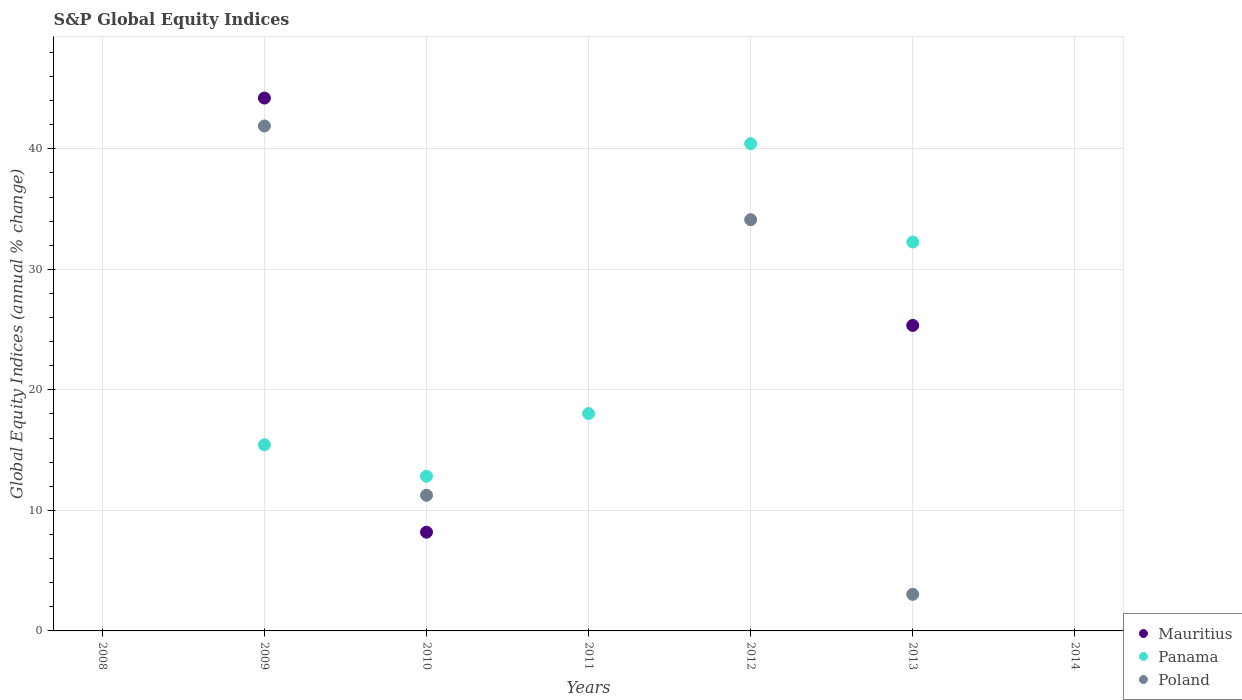What is the global equity indices in Panama in 2011?
Offer a very short reply. 18.04. Across all years, what is the maximum global equity indices in Mauritius?
Your answer should be very brief. 44.22. Across all years, what is the minimum global equity indices in Poland?
Offer a terse response. 0. In which year was the global equity indices in Panama maximum?
Your answer should be very brief. 2012. What is the total global equity indices in Panama in the graph?
Offer a terse response. 119.02. What is the difference between the global equity indices in Poland in 2009 and that in 2010?
Keep it short and to the point. 30.64. What is the difference between the global equity indices in Mauritius in 2011 and the global equity indices in Poland in 2012?
Make the answer very short. -34.12. What is the average global equity indices in Mauritius per year?
Offer a terse response. 11.11. In the year 2010, what is the difference between the global equity indices in Poland and global equity indices in Panama?
Your answer should be very brief. -1.58. Is the global equity indices in Poland in 2012 less than that in 2013?
Keep it short and to the point. No. What is the difference between the highest and the second highest global equity indices in Poland?
Your response must be concise. 7.78. What is the difference between the highest and the lowest global equity indices in Panama?
Keep it short and to the point. 40.43. In how many years, is the global equity indices in Mauritius greater than the average global equity indices in Mauritius taken over all years?
Give a very brief answer. 2. Does the global equity indices in Poland monotonically increase over the years?
Keep it short and to the point. No. Is the global equity indices in Panama strictly less than the global equity indices in Mauritius over the years?
Provide a short and direct response. No. How many dotlines are there?
Give a very brief answer. 3. What is the difference between two consecutive major ticks on the Y-axis?
Offer a very short reply. 10. Are the values on the major ticks of Y-axis written in scientific E-notation?
Make the answer very short. No. Does the graph contain any zero values?
Your answer should be compact. Yes. Where does the legend appear in the graph?
Your response must be concise. Bottom right. How are the legend labels stacked?
Your response must be concise. Vertical. What is the title of the graph?
Offer a terse response. S&P Global Equity Indices. What is the label or title of the X-axis?
Your answer should be compact. Years. What is the label or title of the Y-axis?
Offer a terse response. Global Equity Indices (annual % change). What is the Global Equity Indices (annual % change) of Panama in 2008?
Offer a very short reply. 0. What is the Global Equity Indices (annual % change) in Poland in 2008?
Your answer should be compact. 0. What is the Global Equity Indices (annual % change) in Mauritius in 2009?
Provide a succinct answer. 44.22. What is the Global Equity Indices (annual % change) in Panama in 2009?
Your answer should be very brief. 15.45. What is the Global Equity Indices (annual % change) of Poland in 2009?
Provide a succinct answer. 41.9. What is the Global Equity Indices (annual % change) in Mauritius in 2010?
Offer a very short reply. 8.19. What is the Global Equity Indices (annual % change) in Panama in 2010?
Keep it short and to the point. 12.83. What is the Global Equity Indices (annual % change) of Poland in 2010?
Make the answer very short. 11.26. What is the Global Equity Indices (annual % change) in Mauritius in 2011?
Offer a terse response. 0. What is the Global Equity Indices (annual % change) of Panama in 2011?
Your answer should be compact. 18.04. What is the Global Equity Indices (annual % change) of Poland in 2011?
Offer a very short reply. 0. What is the Global Equity Indices (annual % change) of Mauritius in 2012?
Your answer should be compact. 0. What is the Global Equity Indices (annual % change) of Panama in 2012?
Provide a short and direct response. 40.43. What is the Global Equity Indices (annual % change) in Poland in 2012?
Your answer should be compact. 34.12. What is the Global Equity Indices (annual % change) in Mauritius in 2013?
Give a very brief answer. 25.35. What is the Global Equity Indices (annual % change) of Panama in 2013?
Your response must be concise. 32.27. What is the Global Equity Indices (annual % change) in Poland in 2013?
Your answer should be very brief. 3.04. What is the Global Equity Indices (annual % change) of Mauritius in 2014?
Keep it short and to the point. 0. What is the Global Equity Indices (annual % change) of Panama in 2014?
Provide a short and direct response. 0. What is the Global Equity Indices (annual % change) in Poland in 2014?
Keep it short and to the point. 0. Across all years, what is the maximum Global Equity Indices (annual % change) in Mauritius?
Keep it short and to the point. 44.22. Across all years, what is the maximum Global Equity Indices (annual % change) in Panama?
Keep it short and to the point. 40.43. Across all years, what is the maximum Global Equity Indices (annual % change) in Poland?
Make the answer very short. 41.9. Across all years, what is the minimum Global Equity Indices (annual % change) of Poland?
Your answer should be very brief. 0. What is the total Global Equity Indices (annual % change) of Mauritius in the graph?
Your answer should be very brief. 77.76. What is the total Global Equity Indices (annual % change) of Panama in the graph?
Give a very brief answer. 119.02. What is the total Global Equity Indices (annual % change) in Poland in the graph?
Offer a terse response. 90.32. What is the difference between the Global Equity Indices (annual % change) of Mauritius in 2009 and that in 2010?
Provide a short and direct response. 36.02. What is the difference between the Global Equity Indices (annual % change) of Panama in 2009 and that in 2010?
Make the answer very short. 2.61. What is the difference between the Global Equity Indices (annual % change) in Poland in 2009 and that in 2010?
Provide a succinct answer. 30.64. What is the difference between the Global Equity Indices (annual % change) in Panama in 2009 and that in 2011?
Keep it short and to the point. -2.59. What is the difference between the Global Equity Indices (annual % change) in Panama in 2009 and that in 2012?
Provide a succinct answer. -24.98. What is the difference between the Global Equity Indices (annual % change) in Poland in 2009 and that in 2012?
Ensure brevity in your answer.  7.78. What is the difference between the Global Equity Indices (annual % change) in Mauritius in 2009 and that in 2013?
Provide a short and direct response. 18.87. What is the difference between the Global Equity Indices (annual % change) of Panama in 2009 and that in 2013?
Your response must be concise. -16.82. What is the difference between the Global Equity Indices (annual % change) in Poland in 2009 and that in 2013?
Ensure brevity in your answer.  38.86. What is the difference between the Global Equity Indices (annual % change) in Panama in 2010 and that in 2011?
Offer a terse response. -5.2. What is the difference between the Global Equity Indices (annual % change) in Panama in 2010 and that in 2012?
Your answer should be very brief. -27.59. What is the difference between the Global Equity Indices (annual % change) of Poland in 2010 and that in 2012?
Ensure brevity in your answer.  -22.86. What is the difference between the Global Equity Indices (annual % change) of Mauritius in 2010 and that in 2013?
Keep it short and to the point. -17.16. What is the difference between the Global Equity Indices (annual % change) of Panama in 2010 and that in 2013?
Provide a succinct answer. -19.44. What is the difference between the Global Equity Indices (annual % change) of Poland in 2010 and that in 2013?
Keep it short and to the point. 8.22. What is the difference between the Global Equity Indices (annual % change) of Panama in 2011 and that in 2012?
Ensure brevity in your answer.  -22.39. What is the difference between the Global Equity Indices (annual % change) of Panama in 2011 and that in 2013?
Keep it short and to the point. -14.23. What is the difference between the Global Equity Indices (annual % change) in Panama in 2012 and that in 2013?
Provide a succinct answer. 8.16. What is the difference between the Global Equity Indices (annual % change) of Poland in 2012 and that in 2013?
Give a very brief answer. 31.09. What is the difference between the Global Equity Indices (annual % change) of Mauritius in 2009 and the Global Equity Indices (annual % change) of Panama in 2010?
Provide a short and direct response. 31.38. What is the difference between the Global Equity Indices (annual % change) in Mauritius in 2009 and the Global Equity Indices (annual % change) in Poland in 2010?
Keep it short and to the point. 32.96. What is the difference between the Global Equity Indices (annual % change) in Panama in 2009 and the Global Equity Indices (annual % change) in Poland in 2010?
Make the answer very short. 4.19. What is the difference between the Global Equity Indices (annual % change) of Mauritius in 2009 and the Global Equity Indices (annual % change) of Panama in 2011?
Keep it short and to the point. 26.18. What is the difference between the Global Equity Indices (annual % change) in Mauritius in 2009 and the Global Equity Indices (annual % change) in Panama in 2012?
Your answer should be compact. 3.79. What is the difference between the Global Equity Indices (annual % change) in Mauritius in 2009 and the Global Equity Indices (annual % change) in Poland in 2012?
Ensure brevity in your answer.  10.09. What is the difference between the Global Equity Indices (annual % change) of Panama in 2009 and the Global Equity Indices (annual % change) of Poland in 2012?
Provide a short and direct response. -18.68. What is the difference between the Global Equity Indices (annual % change) of Mauritius in 2009 and the Global Equity Indices (annual % change) of Panama in 2013?
Offer a very short reply. 11.95. What is the difference between the Global Equity Indices (annual % change) in Mauritius in 2009 and the Global Equity Indices (annual % change) in Poland in 2013?
Offer a very short reply. 41.18. What is the difference between the Global Equity Indices (annual % change) of Panama in 2009 and the Global Equity Indices (annual % change) of Poland in 2013?
Provide a succinct answer. 12.41. What is the difference between the Global Equity Indices (annual % change) in Mauritius in 2010 and the Global Equity Indices (annual % change) in Panama in 2011?
Make the answer very short. -9.84. What is the difference between the Global Equity Indices (annual % change) in Mauritius in 2010 and the Global Equity Indices (annual % change) in Panama in 2012?
Your response must be concise. -32.24. What is the difference between the Global Equity Indices (annual % change) in Mauritius in 2010 and the Global Equity Indices (annual % change) in Poland in 2012?
Provide a succinct answer. -25.93. What is the difference between the Global Equity Indices (annual % change) of Panama in 2010 and the Global Equity Indices (annual % change) of Poland in 2012?
Keep it short and to the point. -21.29. What is the difference between the Global Equity Indices (annual % change) of Mauritius in 2010 and the Global Equity Indices (annual % change) of Panama in 2013?
Ensure brevity in your answer.  -24.08. What is the difference between the Global Equity Indices (annual % change) in Mauritius in 2010 and the Global Equity Indices (annual % change) in Poland in 2013?
Your response must be concise. 5.16. What is the difference between the Global Equity Indices (annual % change) of Panama in 2010 and the Global Equity Indices (annual % change) of Poland in 2013?
Your answer should be compact. 9.8. What is the difference between the Global Equity Indices (annual % change) of Panama in 2011 and the Global Equity Indices (annual % change) of Poland in 2012?
Offer a terse response. -16.09. What is the difference between the Global Equity Indices (annual % change) of Panama in 2011 and the Global Equity Indices (annual % change) of Poland in 2013?
Provide a succinct answer. 15. What is the difference between the Global Equity Indices (annual % change) in Panama in 2012 and the Global Equity Indices (annual % change) in Poland in 2013?
Your response must be concise. 37.39. What is the average Global Equity Indices (annual % change) in Mauritius per year?
Your answer should be very brief. 11.11. What is the average Global Equity Indices (annual % change) in Panama per year?
Your answer should be very brief. 17. What is the average Global Equity Indices (annual % change) in Poland per year?
Provide a succinct answer. 12.9. In the year 2009, what is the difference between the Global Equity Indices (annual % change) in Mauritius and Global Equity Indices (annual % change) in Panama?
Your answer should be compact. 28.77. In the year 2009, what is the difference between the Global Equity Indices (annual % change) in Mauritius and Global Equity Indices (annual % change) in Poland?
Offer a terse response. 2.32. In the year 2009, what is the difference between the Global Equity Indices (annual % change) in Panama and Global Equity Indices (annual % change) in Poland?
Your answer should be very brief. -26.45. In the year 2010, what is the difference between the Global Equity Indices (annual % change) in Mauritius and Global Equity Indices (annual % change) in Panama?
Provide a succinct answer. -4.64. In the year 2010, what is the difference between the Global Equity Indices (annual % change) in Mauritius and Global Equity Indices (annual % change) in Poland?
Provide a succinct answer. -3.07. In the year 2010, what is the difference between the Global Equity Indices (annual % change) in Panama and Global Equity Indices (annual % change) in Poland?
Give a very brief answer. 1.58. In the year 2012, what is the difference between the Global Equity Indices (annual % change) of Panama and Global Equity Indices (annual % change) of Poland?
Your response must be concise. 6.31. In the year 2013, what is the difference between the Global Equity Indices (annual % change) of Mauritius and Global Equity Indices (annual % change) of Panama?
Provide a short and direct response. -6.92. In the year 2013, what is the difference between the Global Equity Indices (annual % change) in Mauritius and Global Equity Indices (annual % change) in Poland?
Provide a succinct answer. 22.31. In the year 2013, what is the difference between the Global Equity Indices (annual % change) of Panama and Global Equity Indices (annual % change) of Poland?
Your answer should be compact. 29.23. What is the ratio of the Global Equity Indices (annual % change) of Mauritius in 2009 to that in 2010?
Your answer should be very brief. 5.4. What is the ratio of the Global Equity Indices (annual % change) in Panama in 2009 to that in 2010?
Give a very brief answer. 1.2. What is the ratio of the Global Equity Indices (annual % change) of Poland in 2009 to that in 2010?
Give a very brief answer. 3.72. What is the ratio of the Global Equity Indices (annual % change) of Panama in 2009 to that in 2011?
Ensure brevity in your answer.  0.86. What is the ratio of the Global Equity Indices (annual % change) in Panama in 2009 to that in 2012?
Provide a succinct answer. 0.38. What is the ratio of the Global Equity Indices (annual % change) in Poland in 2009 to that in 2012?
Offer a very short reply. 1.23. What is the ratio of the Global Equity Indices (annual % change) of Mauritius in 2009 to that in 2013?
Give a very brief answer. 1.74. What is the ratio of the Global Equity Indices (annual % change) of Panama in 2009 to that in 2013?
Give a very brief answer. 0.48. What is the ratio of the Global Equity Indices (annual % change) of Poland in 2009 to that in 2013?
Your answer should be compact. 13.8. What is the ratio of the Global Equity Indices (annual % change) of Panama in 2010 to that in 2011?
Your answer should be compact. 0.71. What is the ratio of the Global Equity Indices (annual % change) in Panama in 2010 to that in 2012?
Offer a very short reply. 0.32. What is the ratio of the Global Equity Indices (annual % change) of Poland in 2010 to that in 2012?
Offer a terse response. 0.33. What is the ratio of the Global Equity Indices (annual % change) in Mauritius in 2010 to that in 2013?
Make the answer very short. 0.32. What is the ratio of the Global Equity Indices (annual % change) of Panama in 2010 to that in 2013?
Provide a short and direct response. 0.4. What is the ratio of the Global Equity Indices (annual % change) in Poland in 2010 to that in 2013?
Provide a short and direct response. 3.71. What is the ratio of the Global Equity Indices (annual % change) in Panama in 2011 to that in 2012?
Give a very brief answer. 0.45. What is the ratio of the Global Equity Indices (annual % change) of Panama in 2011 to that in 2013?
Make the answer very short. 0.56. What is the ratio of the Global Equity Indices (annual % change) in Panama in 2012 to that in 2013?
Provide a short and direct response. 1.25. What is the ratio of the Global Equity Indices (annual % change) of Poland in 2012 to that in 2013?
Provide a short and direct response. 11.24. What is the difference between the highest and the second highest Global Equity Indices (annual % change) of Mauritius?
Provide a succinct answer. 18.87. What is the difference between the highest and the second highest Global Equity Indices (annual % change) of Panama?
Your response must be concise. 8.16. What is the difference between the highest and the second highest Global Equity Indices (annual % change) of Poland?
Keep it short and to the point. 7.78. What is the difference between the highest and the lowest Global Equity Indices (annual % change) of Mauritius?
Offer a very short reply. 44.22. What is the difference between the highest and the lowest Global Equity Indices (annual % change) in Panama?
Ensure brevity in your answer.  40.43. What is the difference between the highest and the lowest Global Equity Indices (annual % change) of Poland?
Your answer should be compact. 41.9. 